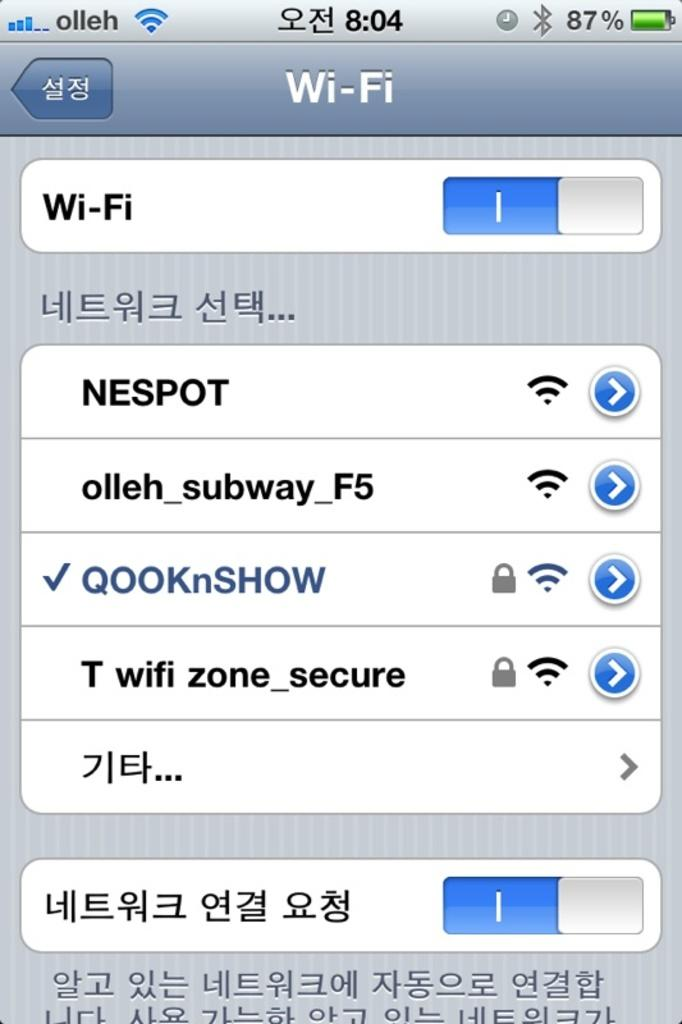<image>
Write a terse but informative summary of the picture. A phone display shows that it is connected to wi-fi. 